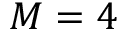<formula> <loc_0><loc_0><loc_500><loc_500>M = 4</formula> 